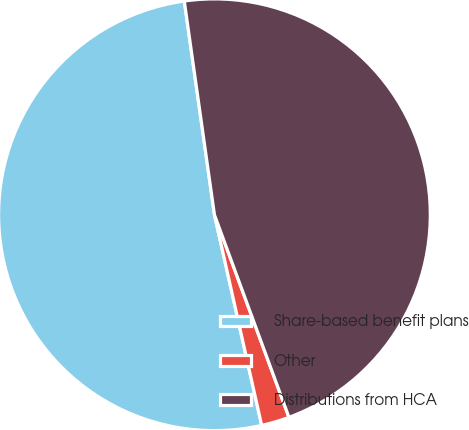<chart> <loc_0><loc_0><loc_500><loc_500><pie_chart><fcel>Share-based benefit plans<fcel>Other<fcel>Distributions from HCA<nl><fcel>51.28%<fcel>2.1%<fcel>46.62%<nl></chart> 